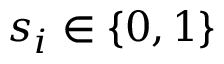<formula> <loc_0><loc_0><loc_500><loc_500>s _ { i } \in \{ 0 , 1 \}</formula> 